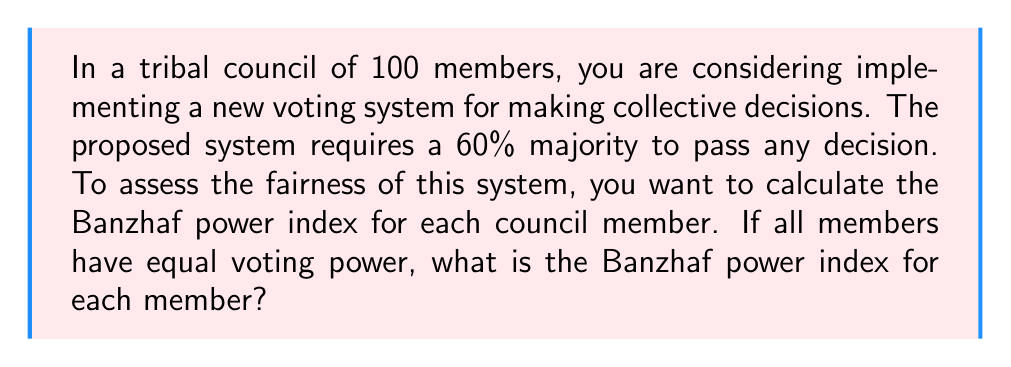Provide a solution to this math problem. To calculate the Banzhaf power index, we need to follow these steps:

1) First, we need to determine the number of winning coalitions. In this case, a winning coalition requires at least 60 votes out of 100.

2) The total number of possible coalitions is $2^{100}$, as each member can either be in or out of a coalition.

3) The number of winning coalitions can be calculated using the binomial distribution:

   $$\sum_{i=60}^{100} \binom{100}{i}$$

4) For each member, we need to calculate the number of times they are critical to a winning coalition. A member is critical if their removal would change a winning coalition to a losing one.

5) The number of critical coalitions for each member is:

   $$\binom{99}{59}$$

   This is because we need exactly 59 votes from the other 99 members, so that the member in question becomes critical.

6) The Banzhaf power index is then calculated as:

   $$\text{Banzhaf Index} = \frac{\text{Number of critical coalitions for a member}}{\text{Total number of critical coalitions for all members}}$$

7) Since all members have equal voting power, the total number of critical coalitions for all members is $100 \times \binom{99}{59}$.

8) Therefore, the Banzhaf power index for each member is:

   $$\text{Banzhaf Index} = \frac{\binom{99}{59}}{100 \times \binom{99}{59}} = \frac{1}{100} = 0.01$$

This means that each member has an equal 1% share of the voting power, which indicates a fair voting system where each member's vote carries equal weight.
Answer: The Banzhaf power index for each member is 0.01 or 1%. 